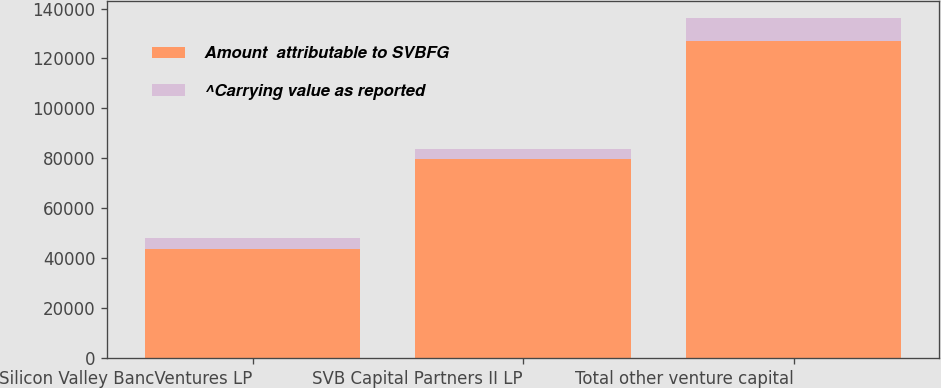Convert chart to OTSL. <chart><loc_0><loc_0><loc_500><loc_500><stacked_bar_chart><ecel><fcel>Silicon Valley BancVentures LP<fcel>SVB Capital Partners II LP<fcel>Total other venture capital<nl><fcel>Amount  attributable to SVBFG<fcel>43493<fcel>79761<fcel>127091<nl><fcel>^Carrying value as reported<fcel>4652<fcel>4051<fcel>8962<nl></chart> 